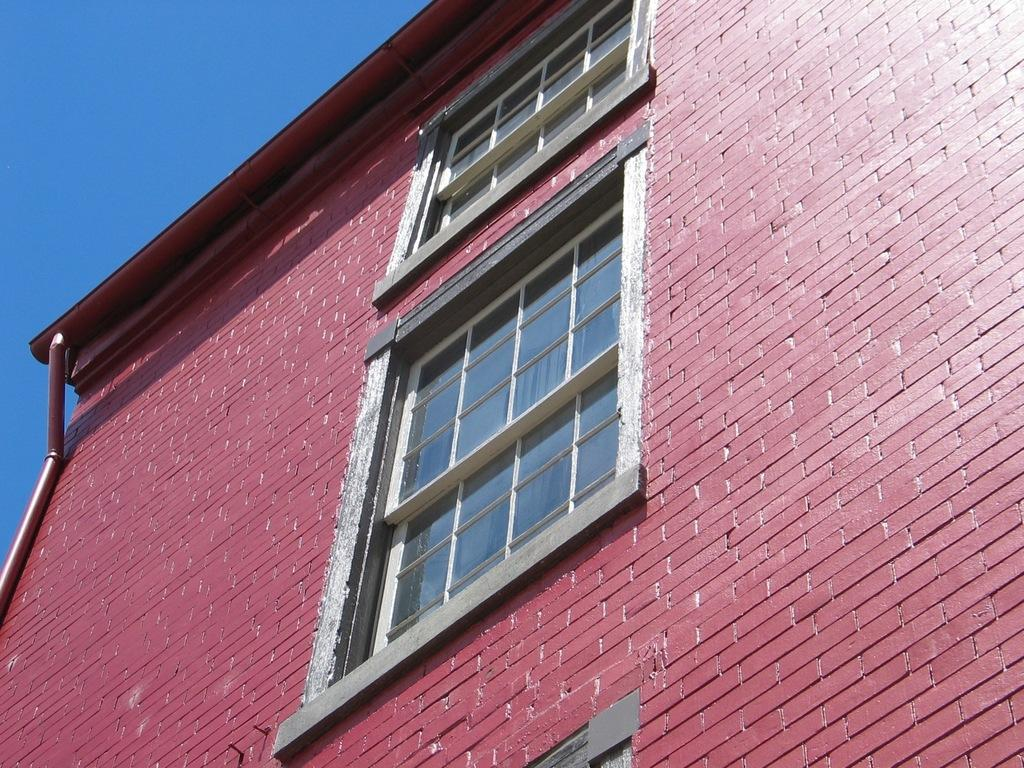What can be seen on the building wall in the image? There is a pipe on the building wall in the image. What is visible in the background of the image? The sky is visible in the background of the image. What architectural feature is present in the image? There are windows in the image. What type of songs can be heard coming from the windows in the image? There is no indication in the image that any songs are being played or heard. Is there a pen visible in the image? There is no pen present in the image. 